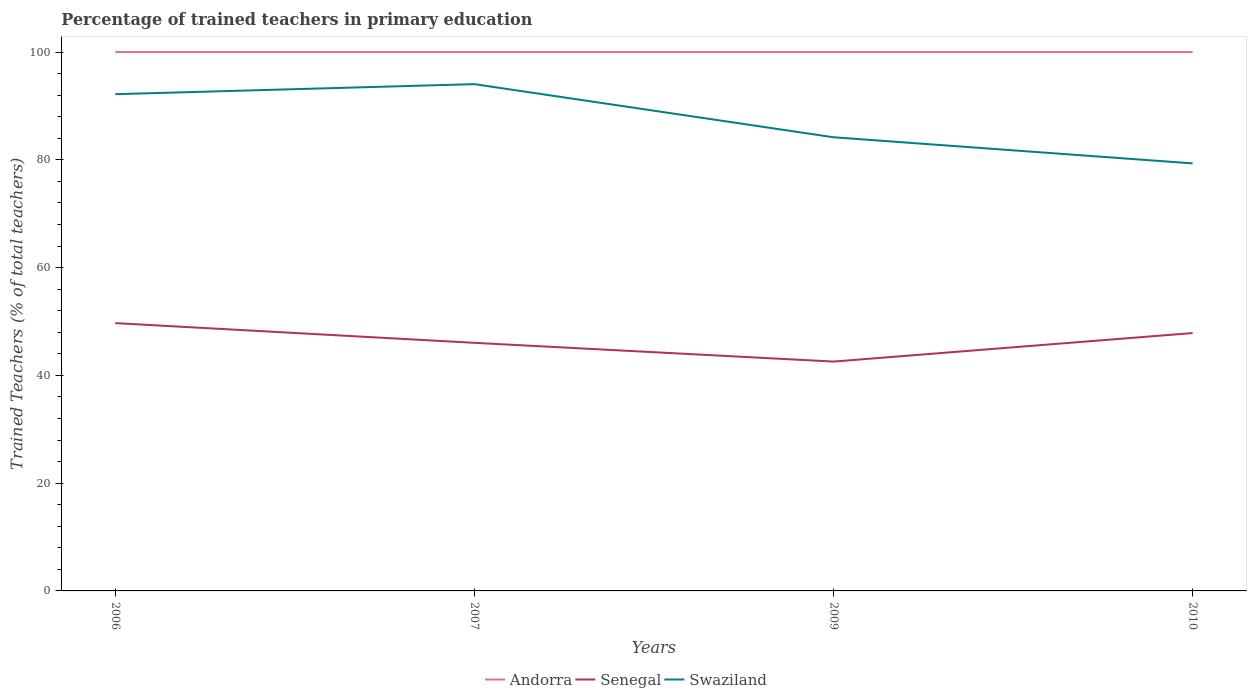How many different coloured lines are there?
Provide a short and direct response. 3. Does the line corresponding to Swaziland intersect with the line corresponding to Senegal?
Offer a very short reply. No. What is the difference between the highest and the second highest percentage of trained teachers in Senegal?
Your answer should be compact. 7.13. Are the values on the major ticks of Y-axis written in scientific E-notation?
Your response must be concise. No. Does the graph contain any zero values?
Ensure brevity in your answer.  No. How many legend labels are there?
Make the answer very short. 3. How are the legend labels stacked?
Provide a short and direct response. Horizontal. What is the title of the graph?
Make the answer very short. Percentage of trained teachers in primary education. What is the label or title of the Y-axis?
Make the answer very short. Trained Teachers (% of total teachers). What is the Trained Teachers (% of total teachers) in Senegal in 2006?
Offer a very short reply. 49.7. What is the Trained Teachers (% of total teachers) of Swaziland in 2006?
Offer a terse response. 92.18. What is the Trained Teachers (% of total teachers) of Senegal in 2007?
Your response must be concise. 46.04. What is the Trained Teachers (% of total teachers) in Swaziland in 2007?
Your answer should be compact. 94.04. What is the Trained Teachers (% of total teachers) in Senegal in 2009?
Offer a terse response. 42.56. What is the Trained Teachers (% of total teachers) of Swaziland in 2009?
Make the answer very short. 84.19. What is the Trained Teachers (% of total teachers) of Senegal in 2010?
Provide a short and direct response. 47.85. What is the Trained Teachers (% of total teachers) in Swaziland in 2010?
Make the answer very short. 79.34. Across all years, what is the maximum Trained Teachers (% of total teachers) of Senegal?
Offer a terse response. 49.7. Across all years, what is the maximum Trained Teachers (% of total teachers) of Swaziland?
Offer a terse response. 94.04. Across all years, what is the minimum Trained Teachers (% of total teachers) in Senegal?
Give a very brief answer. 42.56. Across all years, what is the minimum Trained Teachers (% of total teachers) in Swaziland?
Offer a very short reply. 79.34. What is the total Trained Teachers (% of total teachers) of Andorra in the graph?
Offer a terse response. 400. What is the total Trained Teachers (% of total teachers) in Senegal in the graph?
Provide a short and direct response. 186.15. What is the total Trained Teachers (% of total teachers) of Swaziland in the graph?
Your answer should be compact. 349.75. What is the difference between the Trained Teachers (% of total teachers) in Andorra in 2006 and that in 2007?
Offer a very short reply. 0. What is the difference between the Trained Teachers (% of total teachers) of Senegal in 2006 and that in 2007?
Ensure brevity in your answer.  3.66. What is the difference between the Trained Teachers (% of total teachers) in Swaziland in 2006 and that in 2007?
Your response must be concise. -1.86. What is the difference between the Trained Teachers (% of total teachers) in Senegal in 2006 and that in 2009?
Offer a terse response. 7.13. What is the difference between the Trained Teachers (% of total teachers) in Swaziland in 2006 and that in 2009?
Give a very brief answer. 7.99. What is the difference between the Trained Teachers (% of total teachers) of Andorra in 2006 and that in 2010?
Ensure brevity in your answer.  0. What is the difference between the Trained Teachers (% of total teachers) of Senegal in 2006 and that in 2010?
Your answer should be compact. 1.84. What is the difference between the Trained Teachers (% of total teachers) in Swaziland in 2006 and that in 2010?
Provide a short and direct response. 12.84. What is the difference between the Trained Teachers (% of total teachers) in Senegal in 2007 and that in 2009?
Give a very brief answer. 3.48. What is the difference between the Trained Teachers (% of total teachers) of Swaziland in 2007 and that in 2009?
Offer a very short reply. 9.86. What is the difference between the Trained Teachers (% of total teachers) in Andorra in 2007 and that in 2010?
Offer a very short reply. 0. What is the difference between the Trained Teachers (% of total teachers) in Senegal in 2007 and that in 2010?
Offer a terse response. -1.81. What is the difference between the Trained Teachers (% of total teachers) in Swaziland in 2007 and that in 2010?
Give a very brief answer. 14.71. What is the difference between the Trained Teachers (% of total teachers) of Senegal in 2009 and that in 2010?
Offer a terse response. -5.29. What is the difference between the Trained Teachers (% of total teachers) in Swaziland in 2009 and that in 2010?
Provide a succinct answer. 4.85. What is the difference between the Trained Teachers (% of total teachers) in Andorra in 2006 and the Trained Teachers (% of total teachers) in Senegal in 2007?
Provide a short and direct response. 53.96. What is the difference between the Trained Teachers (% of total teachers) of Andorra in 2006 and the Trained Teachers (% of total teachers) of Swaziland in 2007?
Your answer should be very brief. 5.96. What is the difference between the Trained Teachers (% of total teachers) of Senegal in 2006 and the Trained Teachers (% of total teachers) of Swaziland in 2007?
Give a very brief answer. -44.35. What is the difference between the Trained Teachers (% of total teachers) in Andorra in 2006 and the Trained Teachers (% of total teachers) in Senegal in 2009?
Your response must be concise. 57.44. What is the difference between the Trained Teachers (% of total teachers) in Andorra in 2006 and the Trained Teachers (% of total teachers) in Swaziland in 2009?
Your answer should be compact. 15.81. What is the difference between the Trained Teachers (% of total teachers) in Senegal in 2006 and the Trained Teachers (% of total teachers) in Swaziland in 2009?
Ensure brevity in your answer.  -34.49. What is the difference between the Trained Teachers (% of total teachers) of Andorra in 2006 and the Trained Teachers (% of total teachers) of Senegal in 2010?
Offer a terse response. 52.15. What is the difference between the Trained Teachers (% of total teachers) in Andorra in 2006 and the Trained Teachers (% of total teachers) in Swaziland in 2010?
Keep it short and to the point. 20.66. What is the difference between the Trained Teachers (% of total teachers) in Senegal in 2006 and the Trained Teachers (% of total teachers) in Swaziland in 2010?
Your answer should be compact. -29.64. What is the difference between the Trained Teachers (% of total teachers) in Andorra in 2007 and the Trained Teachers (% of total teachers) in Senegal in 2009?
Make the answer very short. 57.44. What is the difference between the Trained Teachers (% of total teachers) in Andorra in 2007 and the Trained Teachers (% of total teachers) in Swaziland in 2009?
Ensure brevity in your answer.  15.81. What is the difference between the Trained Teachers (% of total teachers) of Senegal in 2007 and the Trained Teachers (% of total teachers) of Swaziland in 2009?
Offer a terse response. -38.15. What is the difference between the Trained Teachers (% of total teachers) in Andorra in 2007 and the Trained Teachers (% of total teachers) in Senegal in 2010?
Keep it short and to the point. 52.15. What is the difference between the Trained Teachers (% of total teachers) in Andorra in 2007 and the Trained Teachers (% of total teachers) in Swaziland in 2010?
Offer a terse response. 20.66. What is the difference between the Trained Teachers (% of total teachers) in Senegal in 2007 and the Trained Teachers (% of total teachers) in Swaziland in 2010?
Make the answer very short. -33.3. What is the difference between the Trained Teachers (% of total teachers) of Andorra in 2009 and the Trained Teachers (% of total teachers) of Senegal in 2010?
Your response must be concise. 52.15. What is the difference between the Trained Teachers (% of total teachers) in Andorra in 2009 and the Trained Teachers (% of total teachers) in Swaziland in 2010?
Make the answer very short. 20.66. What is the difference between the Trained Teachers (% of total teachers) in Senegal in 2009 and the Trained Teachers (% of total teachers) in Swaziland in 2010?
Provide a short and direct response. -36.78. What is the average Trained Teachers (% of total teachers) in Andorra per year?
Provide a short and direct response. 100. What is the average Trained Teachers (% of total teachers) of Senegal per year?
Give a very brief answer. 46.54. What is the average Trained Teachers (% of total teachers) in Swaziland per year?
Make the answer very short. 87.44. In the year 2006, what is the difference between the Trained Teachers (% of total teachers) in Andorra and Trained Teachers (% of total teachers) in Senegal?
Make the answer very short. 50.3. In the year 2006, what is the difference between the Trained Teachers (% of total teachers) in Andorra and Trained Teachers (% of total teachers) in Swaziland?
Ensure brevity in your answer.  7.82. In the year 2006, what is the difference between the Trained Teachers (% of total teachers) in Senegal and Trained Teachers (% of total teachers) in Swaziland?
Your answer should be very brief. -42.49. In the year 2007, what is the difference between the Trained Teachers (% of total teachers) in Andorra and Trained Teachers (% of total teachers) in Senegal?
Your answer should be very brief. 53.96. In the year 2007, what is the difference between the Trained Teachers (% of total teachers) of Andorra and Trained Teachers (% of total teachers) of Swaziland?
Keep it short and to the point. 5.96. In the year 2007, what is the difference between the Trained Teachers (% of total teachers) in Senegal and Trained Teachers (% of total teachers) in Swaziland?
Offer a terse response. -48.01. In the year 2009, what is the difference between the Trained Teachers (% of total teachers) of Andorra and Trained Teachers (% of total teachers) of Senegal?
Give a very brief answer. 57.44. In the year 2009, what is the difference between the Trained Teachers (% of total teachers) of Andorra and Trained Teachers (% of total teachers) of Swaziland?
Make the answer very short. 15.81. In the year 2009, what is the difference between the Trained Teachers (% of total teachers) in Senegal and Trained Teachers (% of total teachers) in Swaziland?
Provide a succinct answer. -41.63. In the year 2010, what is the difference between the Trained Teachers (% of total teachers) of Andorra and Trained Teachers (% of total teachers) of Senegal?
Your response must be concise. 52.15. In the year 2010, what is the difference between the Trained Teachers (% of total teachers) of Andorra and Trained Teachers (% of total teachers) of Swaziland?
Offer a terse response. 20.66. In the year 2010, what is the difference between the Trained Teachers (% of total teachers) of Senegal and Trained Teachers (% of total teachers) of Swaziland?
Offer a terse response. -31.49. What is the ratio of the Trained Teachers (% of total teachers) in Andorra in 2006 to that in 2007?
Your response must be concise. 1. What is the ratio of the Trained Teachers (% of total teachers) of Senegal in 2006 to that in 2007?
Make the answer very short. 1.08. What is the ratio of the Trained Teachers (% of total teachers) of Swaziland in 2006 to that in 2007?
Provide a succinct answer. 0.98. What is the ratio of the Trained Teachers (% of total teachers) of Andorra in 2006 to that in 2009?
Offer a very short reply. 1. What is the ratio of the Trained Teachers (% of total teachers) in Senegal in 2006 to that in 2009?
Make the answer very short. 1.17. What is the ratio of the Trained Teachers (% of total teachers) of Swaziland in 2006 to that in 2009?
Your answer should be compact. 1.09. What is the ratio of the Trained Teachers (% of total teachers) of Swaziland in 2006 to that in 2010?
Your answer should be very brief. 1.16. What is the ratio of the Trained Teachers (% of total teachers) of Andorra in 2007 to that in 2009?
Offer a terse response. 1. What is the ratio of the Trained Teachers (% of total teachers) of Senegal in 2007 to that in 2009?
Provide a short and direct response. 1.08. What is the ratio of the Trained Teachers (% of total teachers) of Swaziland in 2007 to that in 2009?
Ensure brevity in your answer.  1.12. What is the ratio of the Trained Teachers (% of total teachers) of Senegal in 2007 to that in 2010?
Offer a terse response. 0.96. What is the ratio of the Trained Teachers (% of total teachers) in Swaziland in 2007 to that in 2010?
Your answer should be very brief. 1.19. What is the ratio of the Trained Teachers (% of total teachers) of Senegal in 2009 to that in 2010?
Your response must be concise. 0.89. What is the ratio of the Trained Teachers (% of total teachers) of Swaziland in 2009 to that in 2010?
Make the answer very short. 1.06. What is the difference between the highest and the second highest Trained Teachers (% of total teachers) of Andorra?
Provide a short and direct response. 0. What is the difference between the highest and the second highest Trained Teachers (% of total teachers) in Senegal?
Provide a short and direct response. 1.84. What is the difference between the highest and the second highest Trained Teachers (% of total teachers) of Swaziland?
Offer a terse response. 1.86. What is the difference between the highest and the lowest Trained Teachers (% of total teachers) of Senegal?
Offer a terse response. 7.13. What is the difference between the highest and the lowest Trained Teachers (% of total teachers) in Swaziland?
Make the answer very short. 14.71. 